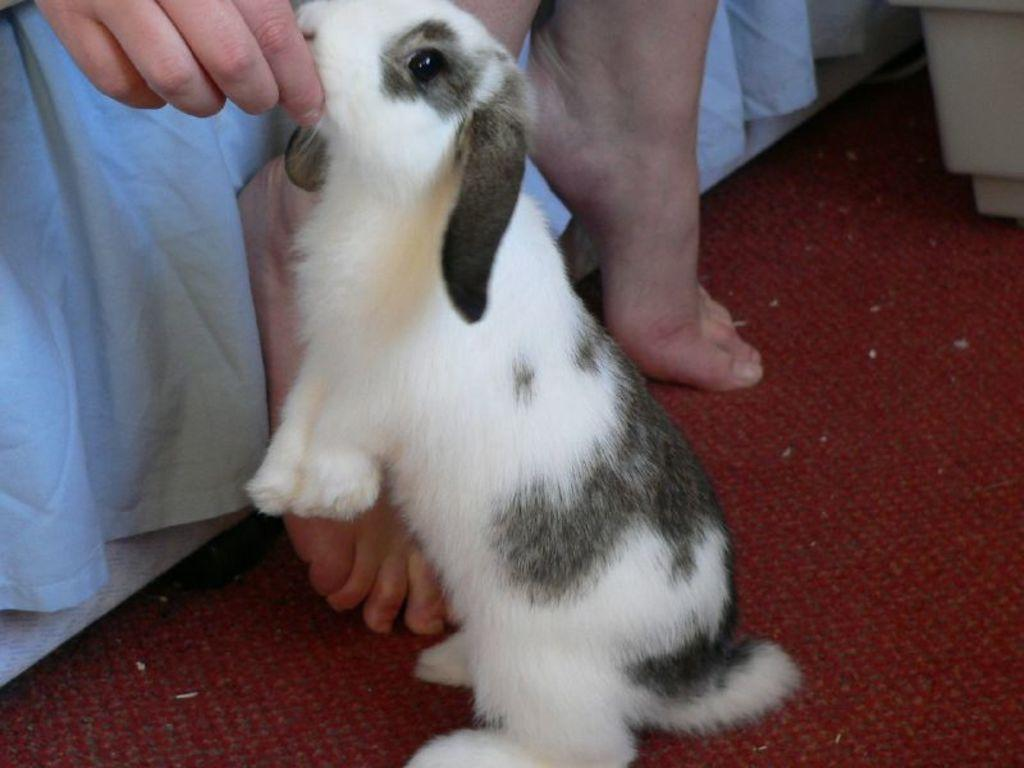What is the main subject of the image? There is a person in the image. What is the person doing in the image? The person is holding a rabbit with his hand. What type of scissors can be seen in the image? There are no scissors present in the image. What type of hat is the person wearing in the image? The person is not wearing a hat in the image. 